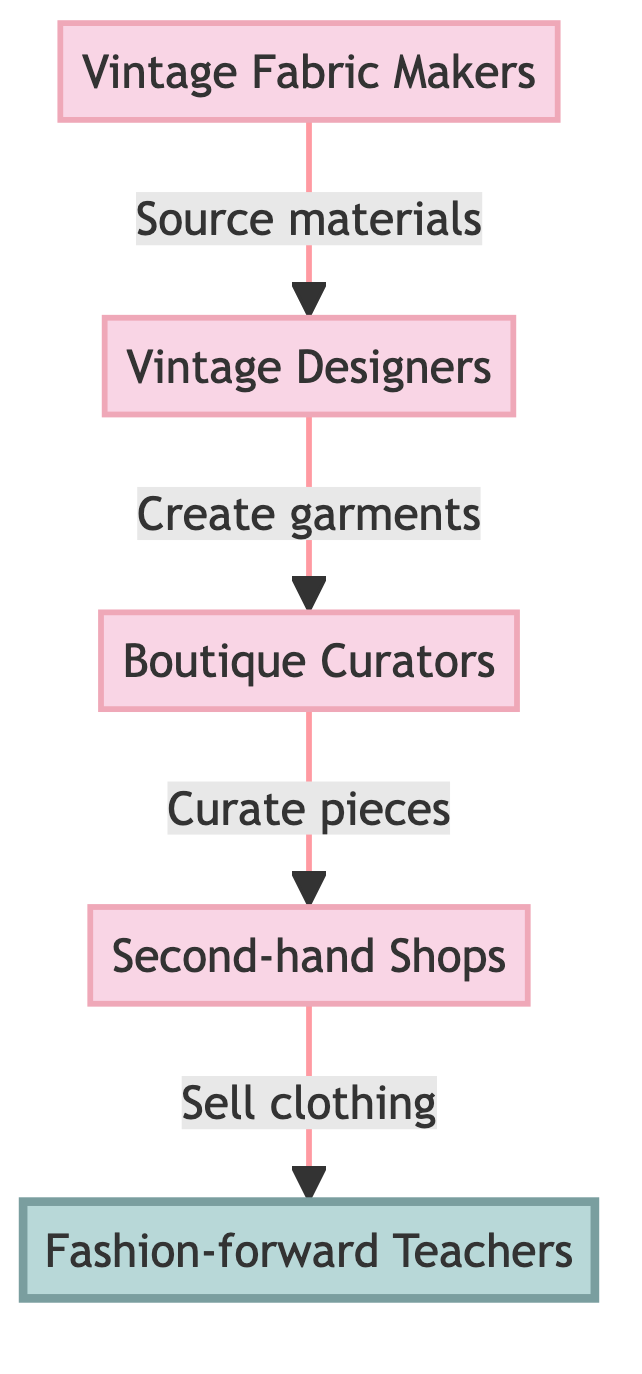What is the starting point of the vintage fashion lifecycle? The diagram indicates that the starting point is the "Vintage Fabric Makers," who are the first node.
Answer: Vintage Fabric Makers How many nodes are present in the diagram? By analyzing the elements represented in the diagram, there are five distinct nodes: Vintage Fabric Makers, Vintage Designers, Boutique Curators, Second-hand Shops, and Fashion-forward Teachers.
Answer: Five Which node comes before the "Second-hand Shops"? The flow shows that the node "Boutique Curators" directly precedes "Second-hand Shops," as indicated by the arrow connecting them.
Answer: Boutique Curators What do "Vintage Designers" create? The arrow indicates that Vintage Designers create "garments," which is the direct output of their role in the lifecycle.
Answer: Garments Who is the final recipient of the clothing in this lifecycle? The final node in the flow diagram represents the "Fashion-forward Teachers," who are the end consumers of the clothing sold by the Second-hand Shops.
Answer: Fashion-forward Teachers What type of materials do "Vintage Fabric Makers" source? The diagram specifies that Vintage Fabric Makers source "materials," which are essential for the subsequent design process.
Answer: Materials Which node is highlighted in the diagram? The highlighted node is "Fashion-forward Teachers," indicating their significance or focus within the lifecycle of vintage fashion.
Answer: Fashion-forward Teachers What is the overall flow direction in this diagram? The arrows connecting the nodes all point in one direction, indicating a clear progression from fabric makers to teachers, illustrating the lifecycle process.
Answer: Forward What is the relationship between "Boutique Curators" and "Vintage Designers"? The arrow indicates that Boutique Curators are connected to Vintage Designers in a sequence where Vintage Designers provide garments that are then curated by Boutique Curators.
Answer: Sequential relationship 